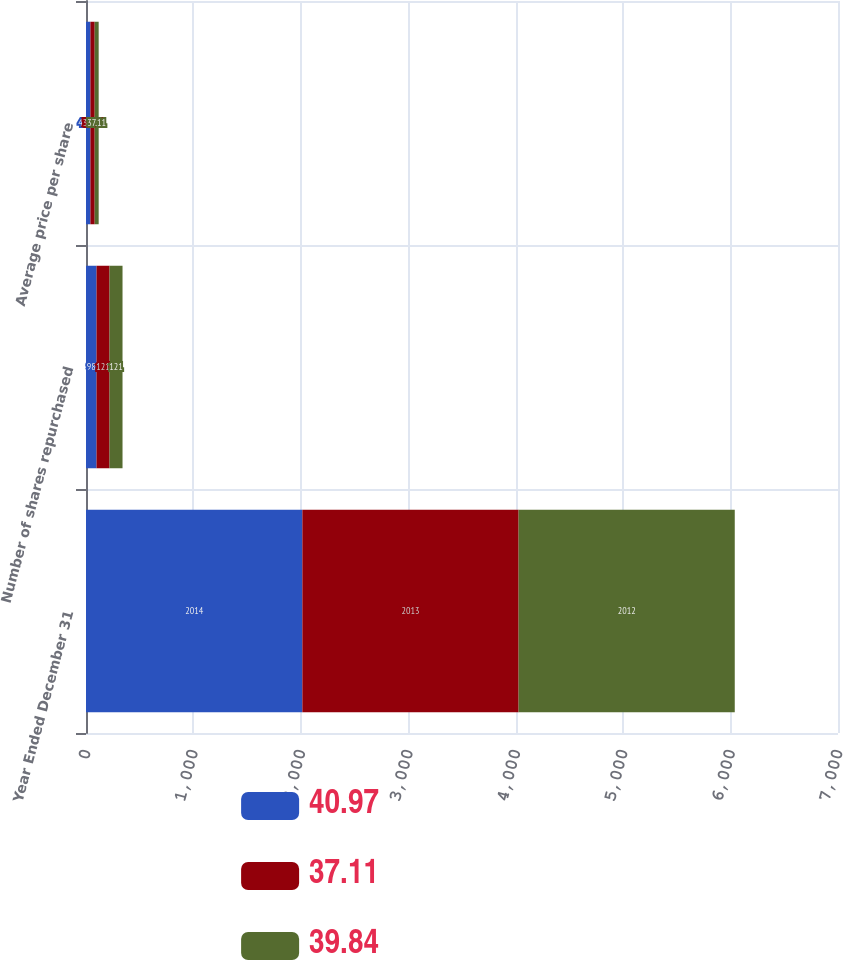<chart> <loc_0><loc_0><loc_500><loc_500><stacked_bar_chart><ecel><fcel>Year Ended December 31<fcel>Number of shares repurchased<fcel>Average price per share<nl><fcel>40.97<fcel>2014<fcel>98<fcel>40.97<nl><fcel>37.11<fcel>2013<fcel>121<fcel>39.84<nl><fcel>39.84<fcel>2012<fcel>121<fcel>37.11<nl></chart> 